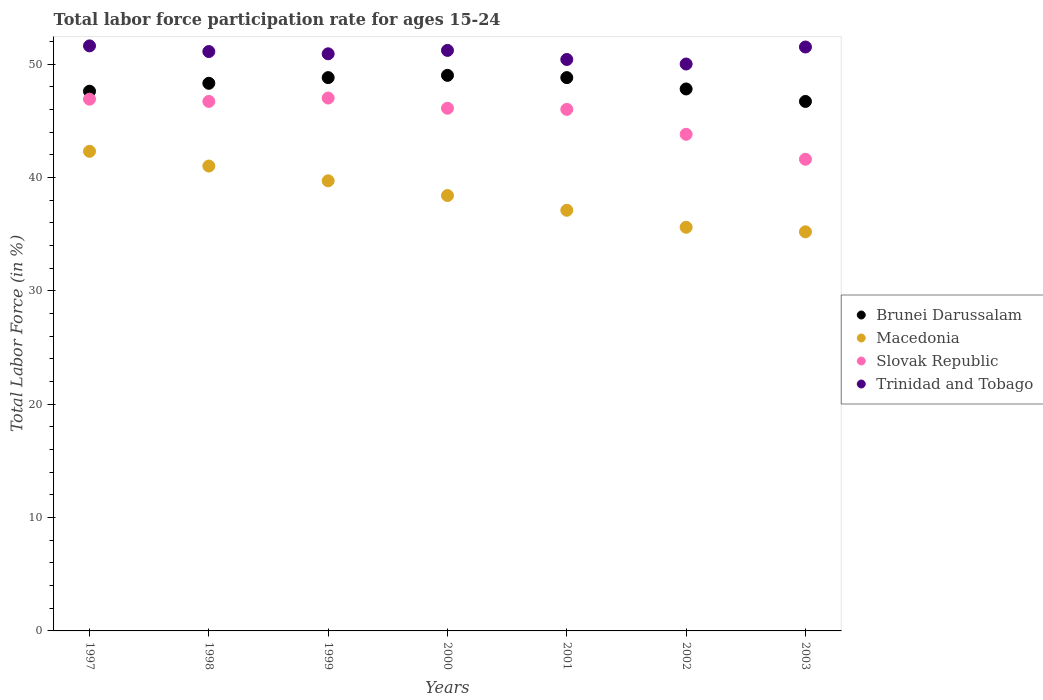How many different coloured dotlines are there?
Provide a succinct answer. 4. What is the labor force participation rate in Brunei Darussalam in 1999?
Offer a very short reply. 48.8. Across all years, what is the maximum labor force participation rate in Trinidad and Tobago?
Provide a succinct answer. 51.6. Across all years, what is the minimum labor force participation rate in Brunei Darussalam?
Provide a short and direct response. 46.7. What is the total labor force participation rate in Trinidad and Tobago in the graph?
Your answer should be very brief. 356.7. What is the difference between the labor force participation rate in Macedonia in 1997 and that in 2002?
Your answer should be very brief. 6.7. What is the difference between the labor force participation rate in Brunei Darussalam in 2003 and the labor force participation rate in Macedonia in 2001?
Provide a short and direct response. 9.6. What is the average labor force participation rate in Trinidad and Tobago per year?
Keep it short and to the point. 50.96. In the year 1999, what is the difference between the labor force participation rate in Slovak Republic and labor force participation rate in Macedonia?
Provide a succinct answer. 7.3. In how many years, is the labor force participation rate in Trinidad and Tobago greater than 50 %?
Give a very brief answer. 6. What is the ratio of the labor force participation rate in Brunei Darussalam in 1997 to that in 1999?
Make the answer very short. 0.98. Is the labor force participation rate in Trinidad and Tobago in 1998 less than that in 2002?
Provide a succinct answer. No. Is the difference between the labor force participation rate in Slovak Republic in 1998 and 2000 greater than the difference between the labor force participation rate in Macedonia in 1998 and 2000?
Your response must be concise. No. What is the difference between the highest and the second highest labor force participation rate in Macedonia?
Provide a short and direct response. 1.3. What is the difference between the highest and the lowest labor force participation rate in Slovak Republic?
Provide a succinct answer. 5.4. In how many years, is the labor force participation rate in Trinidad and Tobago greater than the average labor force participation rate in Trinidad and Tobago taken over all years?
Your answer should be compact. 4. Is the sum of the labor force participation rate in Macedonia in 1997 and 2003 greater than the maximum labor force participation rate in Trinidad and Tobago across all years?
Give a very brief answer. Yes. How many years are there in the graph?
Your response must be concise. 7. Does the graph contain any zero values?
Your answer should be compact. No. Does the graph contain grids?
Make the answer very short. No. What is the title of the graph?
Give a very brief answer. Total labor force participation rate for ages 15-24. Does "Djibouti" appear as one of the legend labels in the graph?
Your answer should be very brief. No. What is the label or title of the X-axis?
Provide a short and direct response. Years. What is the Total Labor Force (in %) of Brunei Darussalam in 1997?
Your response must be concise. 47.6. What is the Total Labor Force (in %) in Macedonia in 1997?
Your answer should be very brief. 42.3. What is the Total Labor Force (in %) in Slovak Republic in 1997?
Make the answer very short. 46.9. What is the Total Labor Force (in %) in Trinidad and Tobago in 1997?
Make the answer very short. 51.6. What is the Total Labor Force (in %) of Brunei Darussalam in 1998?
Make the answer very short. 48.3. What is the Total Labor Force (in %) of Macedonia in 1998?
Give a very brief answer. 41. What is the Total Labor Force (in %) in Slovak Republic in 1998?
Provide a short and direct response. 46.7. What is the Total Labor Force (in %) in Trinidad and Tobago in 1998?
Make the answer very short. 51.1. What is the Total Labor Force (in %) of Brunei Darussalam in 1999?
Provide a short and direct response. 48.8. What is the Total Labor Force (in %) in Macedonia in 1999?
Your answer should be very brief. 39.7. What is the Total Labor Force (in %) in Trinidad and Tobago in 1999?
Offer a terse response. 50.9. What is the Total Labor Force (in %) in Brunei Darussalam in 2000?
Provide a short and direct response. 49. What is the Total Labor Force (in %) of Macedonia in 2000?
Offer a very short reply. 38.4. What is the Total Labor Force (in %) of Slovak Republic in 2000?
Provide a short and direct response. 46.1. What is the Total Labor Force (in %) of Trinidad and Tobago in 2000?
Give a very brief answer. 51.2. What is the Total Labor Force (in %) in Brunei Darussalam in 2001?
Give a very brief answer. 48.8. What is the Total Labor Force (in %) in Macedonia in 2001?
Your answer should be compact. 37.1. What is the Total Labor Force (in %) in Slovak Republic in 2001?
Make the answer very short. 46. What is the Total Labor Force (in %) in Trinidad and Tobago in 2001?
Provide a succinct answer. 50.4. What is the Total Labor Force (in %) in Brunei Darussalam in 2002?
Your answer should be very brief. 47.8. What is the Total Labor Force (in %) in Macedonia in 2002?
Your response must be concise. 35.6. What is the Total Labor Force (in %) in Slovak Republic in 2002?
Your answer should be very brief. 43.8. What is the Total Labor Force (in %) in Trinidad and Tobago in 2002?
Keep it short and to the point. 50. What is the Total Labor Force (in %) of Brunei Darussalam in 2003?
Make the answer very short. 46.7. What is the Total Labor Force (in %) in Macedonia in 2003?
Make the answer very short. 35.2. What is the Total Labor Force (in %) in Slovak Republic in 2003?
Your answer should be very brief. 41.6. What is the Total Labor Force (in %) in Trinidad and Tobago in 2003?
Provide a succinct answer. 51.5. Across all years, what is the maximum Total Labor Force (in %) in Macedonia?
Keep it short and to the point. 42.3. Across all years, what is the maximum Total Labor Force (in %) of Trinidad and Tobago?
Give a very brief answer. 51.6. Across all years, what is the minimum Total Labor Force (in %) of Brunei Darussalam?
Give a very brief answer. 46.7. Across all years, what is the minimum Total Labor Force (in %) of Macedonia?
Give a very brief answer. 35.2. Across all years, what is the minimum Total Labor Force (in %) in Slovak Republic?
Offer a terse response. 41.6. What is the total Total Labor Force (in %) of Brunei Darussalam in the graph?
Offer a terse response. 337. What is the total Total Labor Force (in %) of Macedonia in the graph?
Provide a short and direct response. 269.3. What is the total Total Labor Force (in %) in Slovak Republic in the graph?
Your answer should be compact. 318.1. What is the total Total Labor Force (in %) in Trinidad and Tobago in the graph?
Ensure brevity in your answer.  356.7. What is the difference between the Total Labor Force (in %) of Slovak Republic in 1997 and that in 1998?
Ensure brevity in your answer.  0.2. What is the difference between the Total Labor Force (in %) of Trinidad and Tobago in 1997 and that in 1998?
Your response must be concise. 0.5. What is the difference between the Total Labor Force (in %) of Macedonia in 1997 and that in 1999?
Make the answer very short. 2.6. What is the difference between the Total Labor Force (in %) in Slovak Republic in 1997 and that in 1999?
Give a very brief answer. -0.1. What is the difference between the Total Labor Force (in %) of Brunei Darussalam in 1997 and that in 2000?
Your response must be concise. -1.4. What is the difference between the Total Labor Force (in %) in Macedonia in 1997 and that in 2000?
Provide a short and direct response. 3.9. What is the difference between the Total Labor Force (in %) in Slovak Republic in 1997 and that in 2000?
Provide a short and direct response. 0.8. What is the difference between the Total Labor Force (in %) of Brunei Darussalam in 1997 and that in 2001?
Keep it short and to the point. -1.2. What is the difference between the Total Labor Force (in %) in Macedonia in 1997 and that in 2001?
Your response must be concise. 5.2. What is the difference between the Total Labor Force (in %) of Slovak Republic in 1997 and that in 2001?
Offer a terse response. 0.9. What is the difference between the Total Labor Force (in %) of Trinidad and Tobago in 1997 and that in 2001?
Give a very brief answer. 1.2. What is the difference between the Total Labor Force (in %) in Brunei Darussalam in 1997 and that in 2002?
Offer a terse response. -0.2. What is the difference between the Total Labor Force (in %) of Slovak Republic in 1997 and that in 2002?
Provide a succinct answer. 3.1. What is the difference between the Total Labor Force (in %) in Trinidad and Tobago in 1997 and that in 2002?
Give a very brief answer. 1.6. What is the difference between the Total Labor Force (in %) in Slovak Republic in 1997 and that in 2003?
Offer a terse response. 5.3. What is the difference between the Total Labor Force (in %) of Slovak Republic in 1998 and that in 2000?
Provide a succinct answer. 0.6. What is the difference between the Total Labor Force (in %) of Trinidad and Tobago in 1998 and that in 2000?
Offer a terse response. -0.1. What is the difference between the Total Labor Force (in %) of Brunei Darussalam in 1998 and that in 2001?
Provide a short and direct response. -0.5. What is the difference between the Total Labor Force (in %) of Brunei Darussalam in 1998 and that in 2002?
Offer a terse response. 0.5. What is the difference between the Total Labor Force (in %) of Macedonia in 1998 and that in 2002?
Keep it short and to the point. 5.4. What is the difference between the Total Labor Force (in %) in Slovak Republic in 1998 and that in 2002?
Keep it short and to the point. 2.9. What is the difference between the Total Labor Force (in %) in Slovak Republic in 1998 and that in 2003?
Your response must be concise. 5.1. What is the difference between the Total Labor Force (in %) of Trinidad and Tobago in 1998 and that in 2003?
Give a very brief answer. -0.4. What is the difference between the Total Labor Force (in %) of Brunei Darussalam in 1999 and that in 2000?
Offer a very short reply. -0.2. What is the difference between the Total Labor Force (in %) in Slovak Republic in 1999 and that in 2000?
Keep it short and to the point. 0.9. What is the difference between the Total Labor Force (in %) of Trinidad and Tobago in 1999 and that in 2000?
Your answer should be compact. -0.3. What is the difference between the Total Labor Force (in %) of Brunei Darussalam in 1999 and that in 2001?
Keep it short and to the point. 0. What is the difference between the Total Labor Force (in %) in Macedonia in 1999 and that in 2001?
Keep it short and to the point. 2.6. What is the difference between the Total Labor Force (in %) of Trinidad and Tobago in 1999 and that in 2001?
Give a very brief answer. 0.5. What is the difference between the Total Labor Force (in %) of Macedonia in 1999 and that in 2002?
Ensure brevity in your answer.  4.1. What is the difference between the Total Labor Force (in %) in Trinidad and Tobago in 1999 and that in 2002?
Make the answer very short. 0.9. What is the difference between the Total Labor Force (in %) of Macedonia in 1999 and that in 2003?
Offer a very short reply. 4.5. What is the difference between the Total Labor Force (in %) of Slovak Republic in 2000 and that in 2001?
Provide a succinct answer. 0.1. What is the difference between the Total Labor Force (in %) of Brunei Darussalam in 2000 and that in 2002?
Give a very brief answer. 1.2. What is the difference between the Total Labor Force (in %) of Slovak Republic in 2000 and that in 2003?
Ensure brevity in your answer.  4.5. What is the difference between the Total Labor Force (in %) in Brunei Darussalam in 2001 and that in 2002?
Your answer should be very brief. 1. What is the difference between the Total Labor Force (in %) in Macedonia in 2001 and that in 2002?
Offer a very short reply. 1.5. What is the difference between the Total Labor Force (in %) of Slovak Republic in 2001 and that in 2002?
Make the answer very short. 2.2. What is the difference between the Total Labor Force (in %) of Slovak Republic in 2001 and that in 2003?
Give a very brief answer. 4.4. What is the difference between the Total Labor Force (in %) in Trinidad and Tobago in 2001 and that in 2003?
Your answer should be compact. -1.1. What is the difference between the Total Labor Force (in %) of Brunei Darussalam in 2002 and that in 2003?
Offer a very short reply. 1.1. What is the difference between the Total Labor Force (in %) in Trinidad and Tobago in 2002 and that in 2003?
Your answer should be very brief. -1.5. What is the difference between the Total Labor Force (in %) of Brunei Darussalam in 1997 and the Total Labor Force (in %) of Macedonia in 1998?
Ensure brevity in your answer.  6.6. What is the difference between the Total Labor Force (in %) in Brunei Darussalam in 1997 and the Total Labor Force (in %) in Trinidad and Tobago in 1998?
Offer a very short reply. -3.5. What is the difference between the Total Labor Force (in %) in Macedonia in 1997 and the Total Labor Force (in %) in Trinidad and Tobago in 1998?
Offer a terse response. -8.8. What is the difference between the Total Labor Force (in %) in Brunei Darussalam in 1997 and the Total Labor Force (in %) in Macedonia in 1999?
Give a very brief answer. 7.9. What is the difference between the Total Labor Force (in %) in Brunei Darussalam in 1997 and the Total Labor Force (in %) in Slovak Republic in 1999?
Provide a short and direct response. 0.6. What is the difference between the Total Labor Force (in %) in Macedonia in 1997 and the Total Labor Force (in %) in Slovak Republic in 1999?
Keep it short and to the point. -4.7. What is the difference between the Total Labor Force (in %) of Macedonia in 1997 and the Total Labor Force (in %) of Trinidad and Tobago in 1999?
Provide a succinct answer. -8.6. What is the difference between the Total Labor Force (in %) in Slovak Republic in 1997 and the Total Labor Force (in %) in Trinidad and Tobago in 1999?
Your answer should be compact. -4. What is the difference between the Total Labor Force (in %) of Brunei Darussalam in 1997 and the Total Labor Force (in %) of Slovak Republic in 2000?
Your response must be concise. 1.5. What is the difference between the Total Labor Force (in %) in Macedonia in 1997 and the Total Labor Force (in %) in Trinidad and Tobago in 2000?
Offer a very short reply. -8.9. What is the difference between the Total Labor Force (in %) of Brunei Darussalam in 1997 and the Total Labor Force (in %) of Slovak Republic in 2001?
Ensure brevity in your answer.  1.6. What is the difference between the Total Labor Force (in %) of Brunei Darussalam in 1997 and the Total Labor Force (in %) of Trinidad and Tobago in 2001?
Make the answer very short. -2.8. What is the difference between the Total Labor Force (in %) in Macedonia in 1997 and the Total Labor Force (in %) in Trinidad and Tobago in 2001?
Offer a very short reply. -8.1. What is the difference between the Total Labor Force (in %) in Slovak Republic in 1997 and the Total Labor Force (in %) in Trinidad and Tobago in 2001?
Your answer should be very brief. -3.5. What is the difference between the Total Labor Force (in %) of Brunei Darussalam in 1997 and the Total Labor Force (in %) of Slovak Republic in 2002?
Provide a short and direct response. 3.8. What is the difference between the Total Labor Force (in %) in Brunei Darussalam in 1997 and the Total Labor Force (in %) in Trinidad and Tobago in 2002?
Keep it short and to the point. -2.4. What is the difference between the Total Labor Force (in %) of Macedonia in 1997 and the Total Labor Force (in %) of Slovak Republic in 2002?
Ensure brevity in your answer.  -1.5. What is the difference between the Total Labor Force (in %) of Slovak Republic in 1997 and the Total Labor Force (in %) of Trinidad and Tobago in 2002?
Give a very brief answer. -3.1. What is the difference between the Total Labor Force (in %) in Brunei Darussalam in 1997 and the Total Labor Force (in %) in Macedonia in 2003?
Provide a short and direct response. 12.4. What is the difference between the Total Labor Force (in %) of Brunei Darussalam in 1997 and the Total Labor Force (in %) of Slovak Republic in 2003?
Provide a short and direct response. 6. What is the difference between the Total Labor Force (in %) of Brunei Darussalam in 1997 and the Total Labor Force (in %) of Trinidad and Tobago in 2003?
Your response must be concise. -3.9. What is the difference between the Total Labor Force (in %) in Macedonia in 1997 and the Total Labor Force (in %) in Slovak Republic in 2003?
Your answer should be very brief. 0.7. What is the difference between the Total Labor Force (in %) in Macedonia in 1997 and the Total Labor Force (in %) in Trinidad and Tobago in 2003?
Give a very brief answer. -9.2. What is the difference between the Total Labor Force (in %) of Brunei Darussalam in 1998 and the Total Labor Force (in %) of Macedonia in 1999?
Keep it short and to the point. 8.6. What is the difference between the Total Labor Force (in %) of Brunei Darussalam in 1998 and the Total Labor Force (in %) of Trinidad and Tobago in 1999?
Make the answer very short. -2.6. What is the difference between the Total Labor Force (in %) of Macedonia in 1998 and the Total Labor Force (in %) of Slovak Republic in 1999?
Your response must be concise. -6. What is the difference between the Total Labor Force (in %) in Brunei Darussalam in 1998 and the Total Labor Force (in %) in Macedonia in 2000?
Provide a succinct answer. 9.9. What is the difference between the Total Labor Force (in %) in Brunei Darussalam in 1998 and the Total Labor Force (in %) in Macedonia in 2001?
Give a very brief answer. 11.2. What is the difference between the Total Labor Force (in %) of Macedonia in 1998 and the Total Labor Force (in %) of Slovak Republic in 2001?
Make the answer very short. -5. What is the difference between the Total Labor Force (in %) of Slovak Republic in 1998 and the Total Labor Force (in %) of Trinidad and Tobago in 2001?
Give a very brief answer. -3.7. What is the difference between the Total Labor Force (in %) in Brunei Darussalam in 1998 and the Total Labor Force (in %) in Macedonia in 2002?
Ensure brevity in your answer.  12.7. What is the difference between the Total Labor Force (in %) in Brunei Darussalam in 1998 and the Total Labor Force (in %) in Slovak Republic in 2002?
Ensure brevity in your answer.  4.5. What is the difference between the Total Labor Force (in %) of Brunei Darussalam in 1998 and the Total Labor Force (in %) of Trinidad and Tobago in 2002?
Your response must be concise. -1.7. What is the difference between the Total Labor Force (in %) of Macedonia in 1998 and the Total Labor Force (in %) of Slovak Republic in 2002?
Your response must be concise. -2.8. What is the difference between the Total Labor Force (in %) of Macedonia in 1998 and the Total Labor Force (in %) of Trinidad and Tobago in 2002?
Your response must be concise. -9. What is the difference between the Total Labor Force (in %) of Slovak Republic in 1998 and the Total Labor Force (in %) of Trinidad and Tobago in 2002?
Provide a succinct answer. -3.3. What is the difference between the Total Labor Force (in %) in Brunei Darussalam in 1998 and the Total Labor Force (in %) in Slovak Republic in 2003?
Your answer should be compact. 6.7. What is the difference between the Total Labor Force (in %) in Macedonia in 1999 and the Total Labor Force (in %) in Slovak Republic in 2000?
Your answer should be very brief. -6.4. What is the difference between the Total Labor Force (in %) of Slovak Republic in 1999 and the Total Labor Force (in %) of Trinidad and Tobago in 2001?
Provide a short and direct response. -3.4. What is the difference between the Total Labor Force (in %) in Brunei Darussalam in 1999 and the Total Labor Force (in %) in Slovak Republic in 2002?
Your response must be concise. 5. What is the difference between the Total Labor Force (in %) of Brunei Darussalam in 1999 and the Total Labor Force (in %) of Trinidad and Tobago in 2002?
Provide a short and direct response. -1.2. What is the difference between the Total Labor Force (in %) in Macedonia in 1999 and the Total Labor Force (in %) in Trinidad and Tobago in 2002?
Make the answer very short. -10.3. What is the difference between the Total Labor Force (in %) of Slovak Republic in 1999 and the Total Labor Force (in %) of Trinidad and Tobago in 2002?
Offer a terse response. -3. What is the difference between the Total Labor Force (in %) in Brunei Darussalam in 1999 and the Total Labor Force (in %) in Macedonia in 2003?
Your response must be concise. 13.6. What is the difference between the Total Labor Force (in %) of Brunei Darussalam in 1999 and the Total Labor Force (in %) of Slovak Republic in 2003?
Ensure brevity in your answer.  7.2. What is the difference between the Total Labor Force (in %) of Brunei Darussalam in 1999 and the Total Labor Force (in %) of Trinidad and Tobago in 2003?
Your answer should be compact. -2.7. What is the difference between the Total Labor Force (in %) in Macedonia in 1999 and the Total Labor Force (in %) in Trinidad and Tobago in 2003?
Ensure brevity in your answer.  -11.8. What is the difference between the Total Labor Force (in %) of Brunei Darussalam in 2000 and the Total Labor Force (in %) of Slovak Republic in 2001?
Ensure brevity in your answer.  3. What is the difference between the Total Labor Force (in %) of Brunei Darussalam in 2000 and the Total Labor Force (in %) of Trinidad and Tobago in 2001?
Offer a terse response. -1.4. What is the difference between the Total Labor Force (in %) of Macedonia in 2000 and the Total Labor Force (in %) of Trinidad and Tobago in 2001?
Give a very brief answer. -12. What is the difference between the Total Labor Force (in %) of Brunei Darussalam in 2000 and the Total Labor Force (in %) of Slovak Republic in 2002?
Offer a terse response. 5.2. What is the difference between the Total Labor Force (in %) in Brunei Darussalam in 2000 and the Total Labor Force (in %) in Trinidad and Tobago in 2002?
Your answer should be compact. -1. What is the difference between the Total Labor Force (in %) of Macedonia in 2000 and the Total Labor Force (in %) of Slovak Republic in 2002?
Offer a terse response. -5.4. What is the difference between the Total Labor Force (in %) in Brunei Darussalam in 2000 and the Total Labor Force (in %) in Slovak Republic in 2003?
Provide a short and direct response. 7.4. What is the difference between the Total Labor Force (in %) in Brunei Darussalam in 2000 and the Total Labor Force (in %) in Trinidad and Tobago in 2003?
Your answer should be very brief. -2.5. What is the difference between the Total Labor Force (in %) of Slovak Republic in 2000 and the Total Labor Force (in %) of Trinidad and Tobago in 2003?
Offer a very short reply. -5.4. What is the difference between the Total Labor Force (in %) in Brunei Darussalam in 2001 and the Total Labor Force (in %) in Macedonia in 2002?
Offer a terse response. 13.2. What is the difference between the Total Labor Force (in %) in Brunei Darussalam in 2001 and the Total Labor Force (in %) in Trinidad and Tobago in 2002?
Ensure brevity in your answer.  -1.2. What is the difference between the Total Labor Force (in %) of Macedonia in 2001 and the Total Labor Force (in %) of Trinidad and Tobago in 2002?
Keep it short and to the point. -12.9. What is the difference between the Total Labor Force (in %) of Slovak Republic in 2001 and the Total Labor Force (in %) of Trinidad and Tobago in 2002?
Keep it short and to the point. -4. What is the difference between the Total Labor Force (in %) of Brunei Darussalam in 2001 and the Total Labor Force (in %) of Macedonia in 2003?
Your answer should be compact. 13.6. What is the difference between the Total Labor Force (in %) of Macedonia in 2001 and the Total Labor Force (in %) of Trinidad and Tobago in 2003?
Make the answer very short. -14.4. What is the difference between the Total Labor Force (in %) in Slovak Republic in 2001 and the Total Labor Force (in %) in Trinidad and Tobago in 2003?
Provide a short and direct response. -5.5. What is the difference between the Total Labor Force (in %) in Brunei Darussalam in 2002 and the Total Labor Force (in %) in Slovak Republic in 2003?
Give a very brief answer. 6.2. What is the difference between the Total Labor Force (in %) in Macedonia in 2002 and the Total Labor Force (in %) in Trinidad and Tobago in 2003?
Your answer should be very brief. -15.9. What is the difference between the Total Labor Force (in %) of Slovak Republic in 2002 and the Total Labor Force (in %) of Trinidad and Tobago in 2003?
Provide a succinct answer. -7.7. What is the average Total Labor Force (in %) in Brunei Darussalam per year?
Your response must be concise. 48.14. What is the average Total Labor Force (in %) of Macedonia per year?
Keep it short and to the point. 38.47. What is the average Total Labor Force (in %) of Slovak Republic per year?
Provide a short and direct response. 45.44. What is the average Total Labor Force (in %) in Trinidad and Tobago per year?
Offer a terse response. 50.96. In the year 1997, what is the difference between the Total Labor Force (in %) of Brunei Darussalam and Total Labor Force (in %) of Slovak Republic?
Make the answer very short. 0.7. In the year 1997, what is the difference between the Total Labor Force (in %) in Brunei Darussalam and Total Labor Force (in %) in Trinidad and Tobago?
Give a very brief answer. -4. In the year 1998, what is the difference between the Total Labor Force (in %) in Brunei Darussalam and Total Labor Force (in %) in Macedonia?
Keep it short and to the point. 7.3. In the year 1998, what is the difference between the Total Labor Force (in %) of Brunei Darussalam and Total Labor Force (in %) of Slovak Republic?
Ensure brevity in your answer.  1.6. In the year 1998, what is the difference between the Total Labor Force (in %) of Brunei Darussalam and Total Labor Force (in %) of Trinidad and Tobago?
Give a very brief answer. -2.8. In the year 1998, what is the difference between the Total Labor Force (in %) of Macedonia and Total Labor Force (in %) of Slovak Republic?
Your answer should be very brief. -5.7. In the year 1998, what is the difference between the Total Labor Force (in %) in Macedonia and Total Labor Force (in %) in Trinidad and Tobago?
Your answer should be compact. -10.1. In the year 1999, what is the difference between the Total Labor Force (in %) of Brunei Darussalam and Total Labor Force (in %) of Macedonia?
Your answer should be very brief. 9.1. In the year 1999, what is the difference between the Total Labor Force (in %) of Brunei Darussalam and Total Labor Force (in %) of Slovak Republic?
Your response must be concise. 1.8. In the year 1999, what is the difference between the Total Labor Force (in %) in Brunei Darussalam and Total Labor Force (in %) in Trinidad and Tobago?
Keep it short and to the point. -2.1. In the year 1999, what is the difference between the Total Labor Force (in %) in Macedonia and Total Labor Force (in %) in Trinidad and Tobago?
Provide a short and direct response. -11.2. In the year 1999, what is the difference between the Total Labor Force (in %) in Slovak Republic and Total Labor Force (in %) in Trinidad and Tobago?
Ensure brevity in your answer.  -3.9. In the year 2000, what is the difference between the Total Labor Force (in %) of Brunei Darussalam and Total Labor Force (in %) of Macedonia?
Keep it short and to the point. 10.6. In the year 2000, what is the difference between the Total Labor Force (in %) in Brunei Darussalam and Total Labor Force (in %) in Trinidad and Tobago?
Offer a terse response. -2.2. In the year 2001, what is the difference between the Total Labor Force (in %) of Brunei Darussalam and Total Labor Force (in %) of Slovak Republic?
Ensure brevity in your answer.  2.8. In the year 2001, what is the difference between the Total Labor Force (in %) in Brunei Darussalam and Total Labor Force (in %) in Trinidad and Tobago?
Give a very brief answer. -1.6. In the year 2001, what is the difference between the Total Labor Force (in %) of Macedonia and Total Labor Force (in %) of Trinidad and Tobago?
Provide a short and direct response. -13.3. In the year 2001, what is the difference between the Total Labor Force (in %) of Slovak Republic and Total Labor Force (in %) of Trinidad and Tobago?
Your response must be concise. -4.4. In the year 2002, what is the difference between the Total Labor Force (in %) in Brunei Darussalam and Total Labor Force (in %) in Macedonia?
Your response must be concise. 12.2. In the year 2002, what is the difference between the Total Labor Force (in %) in Brunei Darussalam and Total Labor Force (in %) in Slovak Republic?
Offer a very short reply. 4. In the year 2002, what is the difference between the Total Labor Force (in %) of Brunei Darussalam and Total Labor Force (in %) of Trinidad and Tobago?
Ensure brevity in your answer.  -2.2. In the year 2002, what is the difference between the Total Labor Force (in %) of Macedonia and Total Labor Force (in %) of Slovak Republic?
Make the answer very short. -8.2. In the year 2002, what is the difference between the Total Labor Force (in %) of Macedonia and Total Labor Force (in %) of Trinidad and Tobago?
Offer a terse response. -14.4. In the year 2002, what is the difference between the Total Labor Force (in %) of Slovak Republic and Total Labor Force (in %) of Trinidad and Tobago?
Provide a short and direct response. -6.2. In the year 2003, what is the difference between the Total Labor Force (in %) in Brunei Darussalam and Total Labor Force (in %) in Slovak Republic?
Keep it short and to the point. 5.1. In the year 2003, what is the difference between the Total Labor Force (in %) in Macedonia and Total Labor Force (in %) in Trinidad and Tobago?
Offer a very short reply. -16.3. In the year 2003, what is the difference between the Total Labor Force (in %) of Slovak Republic and Total Labor Force (in %) of Trinidad and Tobago?
Keep it short and to the point. -9.9. What is the ratio of the Total Labor Force (in %) of Brunei Darussalam in 1997 to that in 1998?
Keep it short and to the point. 0.99. What is the ratio of the Total Labor Force (in %) in Macedonia in 1997 to that in 1998?
Ensure brevity in your answer.  1.03. What is the ratio of the Total Labor Force (in %) of Trinidad and Tobago in 1997 to that in 1998?
Keep it short and to the point. 1.01. What is the ratio of the Total Labor Force (in %) in Brunei Darussalam in 1997 to that in 1999?
Provide a short and direct response. 0.98. What is the ratio of the Total Labor Force (in %) in Macedonia in 1997 to that in 1999?
Your answer should be very brief. 1.07. What is the ratio of the Total Labor Force (in %) in Slovak Republic in 1997 to that in 1999?
Make the answer very short. 1. What is the ratio of the Total Labor Force (in %) in Trinidad and Tobago in 1997 to that in 1999?
Provide a succinct answer. 1.01. What is the ratio of the Total Labor Force (in %) of Brunei Darussalam in 1997 to that in 2000?
Offer a very short reply. 0.97. What is the ratio of the Total Labor Force (in %) of Macedonia in 1997 to that in 2000?
Your answer should be very brief. 1.1. What is the ratio of the Total Labor Force (in %) in Slovak Republic in 1997 to that in 2000?
Your answer should be compact. 1.02. What is the ratio of the Total Labor Force (in %) of Brunei Darussalam in 1997 to that in 2001?
Make the answer very short. 0.98. What is the ratio of the Total Labor Force (in %) of Macedonia in 1997 to that in 2001?
Ensure brevity in your answer.  1.14. What is the ratio of the Total Labor Force (in %) of Slovak Republic in 1997 to that in 2001?
Offer a very short reply. 1.02. What is the ratio of the Total Labor Force (in %) in Trinidad and Tobago in 1997 to that in 2001?
Your answer should be very brief. 1.02. What is the ratio of the Total Labor Force (in %) in Macedonia in 1997 to that in 2002?
Make the answer very short. 1.19. What is the ratio of the Total Labor Force (in %) in Slovak Republic in 1997 to that in 2002?
Offer a very short reply. 1.07. What is the ratio of the Total Labor Force (in %) in Trinidad and Tobago in 1997 to that in 2002?
Provide a short and direct response. 1.03. What is the ratio of the Total Labor Force (in %) of Brunei Darussalam in 1997 to that in 2003?
Provide a short and direct response. 1.02. What is the ratio of the Total Labor Force (in %) of Macedonia in 1997 to that in 2003?
Offer a terse response. 1.2. What is the ratio of the Total Labor Force (in %) in Slovak Republic in 1997 to that in 2003?
Provide a short and direct response. 1.13. What is the ratio of the Total Labor Force (in %) of Macedonia in 1998 to that in 1999?
Keep it short and to the point. 1.03. What is the ratio of the Total Labor Force (in %) in Trinidad and Tobago in 1998 to that in 1999?
Provide a succinct answer. 1. What is the ratio of the Total Labor Force (in %) in Brunei Darussalam in 1998 to that in 2000?
Provide a succinct answer. 0.99. What is the ratio of the Total Labor Force (in %) of Macedonia in 1998 to that in 2000?
Your response must be concise. 1.07. What is the ratio of the Total Labor Force (in %) of Slovak Republic in 1998 to that in 2000?
Your response must be concise. 1.01. What is the ratio of the Total Labor Force (in %) in Brunei Darussalam in 1998 to that in 2001?
Provide a succinct answer. 0.99. What is the ratio of the Total Labor Force (in %) in Macedonia in 1998 to that in 2001?
Keep it short and to the point. 1.11. What is the ratio of the Total Labor Force (in %) of Slovak Republic in 1998 to that in 2001?
Your response must be concise. 1.02. What is the ratio of the Total Labor Force (in %) of Trinidad and Tobago in 1998 to that in 2001?
Give a very brief answer. 1.01. What is the ratio of the Total Labor Force (in %) of Brunei Darussalam in 1998 to that in 2002?
Offer a very short reply. 1.01. What is the ratio of the Total Labor Force (in %) in Macedonia in 1998 to that in 2002?
Make the answer very short. 1.15. What is the ratio of the Total Labor Force (in %) in Slovak Republic in 1998 to that in 2002?
Ensure brevity in your answer.  1.07. What is the ratio of the Total Labor Force (in %) in Trinidad and Tobago in 1998 to that in 2002?
Your response must be concise. 1.02. What is the ratio of the Total Labor Force (in %) of Brunei Darussalam in 1998 to that in 2003?
Your answer should be very brief. 1.03. What is the ratio of the Total Labor Force (in %) of Macedonia in 1998 to that in 2003?
Give a very brief answer. 1.16. What is the ratio of the Total Labor Force (in %) of Slovak Republic in 1998 to that in 2003?
Give a very brief answer. 1.12. What is the ratio of the Total Labor Force (in %) of Trinidad and Tobago in 1998 to that in 2003?
Give a very brief answer. 0.99. What is the ratio of the Total Labor Force (in %) in Brunei Darussalam in 1999 to that in 2000?
Give a very brief answer. 1. What is the ratio of the Total Labor Force (in %) in Macedonia in 1999 to that in 2000?
Your answer should be compact. 1.03. What is the ratio of the Total Labor Force (in %) of Slovak Republic in 1999 to that in 2000?
Provide a short and direct response. 1.02. What is the ratio of the Total Labor Force (in %) in Macedonia in 1999 to that in 2001?
Offer a terse response. 1.07. What is the ratio of the Total Labor Force (in %) in Slovak Republic in 1999 to that in 2001?
Provide a short and direct response. 1.02. What is the ratio of the Total Labor Force (in %) of Trinidad and Tobago in 1999 to that in 2001?
Ensure brevity in your answer.  1.01. What is the ratio of the Total Labor Force (in %) of Brunei Darussalam in 1999 to that in 2002?
Offer a very short reply. 1.02. What is the ratio of the Total Labor Force (in %) of Macedonia in 1999 to that in 2002?
Provide a succinct answer. 1.12. What is the ratio of the Total Labor Force (in %) of Slovak Republic in 1999 to that in 2002?
Offer a very short reply. 1.07. What is the ratio of the Total Labor Force (in %) in Brunei Darussalam in 1999 to that in 2003?
Provide a short and direct response. 1.04. What is the ratio of the Total Labor Force (in %) in Macedonia in 1999 to that in 2003?
Offer a terse response. 1.13. What is the ratio of the Total Labor Force (in %) in Slovak Republic in 1999 to that in 2003?
Your answer should be compact. 1.13. What is the ratio of the Total Labor Force (in %) of Trinidad and Tobago in 1999 to that in 2003?
Offer a terse response. 0.99. What is the ratio of the Total Labor Force (in %) of Macedonia in 2000 to that in 2001?
Give a very brief answer. 1.03. What is the ratio of the Total Labor Force (in %) in Slovak Republic in 2000 to that in 2001?
Make the answer very short. 1. What is the ratio of the Total Labor Force (in %) in Trinidad and Tobago in 2000 to that in 2001?
Offer a very short reply. 1.02. What is the ratio of the Total Labor Force (in %) of Brunei Darussalam in 2000 to that in 2002?
Provide a short and direct response. 1.03. What is the ratio of the Total Labor Force (in %) of Macedonia in 2000 to that in 2002?
Keep it short and to the point. 1.08. What is the ratio of the Total Labor Force (in %) in Slovak Republic in 2000 to that in 2002?
Offer a terse response. 1.05. What is the ratio of the Total Labor Force (in %) in Trinidad and Tobago in 2000 to that in 2002?
Ensure brevity in your answer.  1.02. What is the ratio of the Total Labor Force (in %) of Brunei Darussalam in 2000 to that in 2003?
Offer a very short reply. 1.05. What is the ratio of the Total Labor Force (in %) of Macedonia in 2000 to that in 2003?
Make the answer very short. 1.09. What is the ratio of the Total Labor Force (in %) in Slovak Republic in 2000 to that in 2003?
Your response must be concise. 1.11. What is the ratio of the Total Labor Force (in %) of Trinidad and Tobago in 2000 to that in 2003?
Your answer should be very brief. 0.99. What is the ratio of the Total Labor Force (in %) in Brunei Darussalam in 2001 to that in 2002?
Ensure brevity in your answer.  1.02. What is the ratio of the Total Labor Force (in %) of Macedonia in 2001 to that in 2002?
Make the answer very short. 1.04. What is the ratio of the Total Labor Force (in %) in Slovak Republic in 2001 to that in 2002?
Your response must be concise. 1.05. What is the ratio of the Total Labor Force (in %) in Trinidad and Tobago in 2001 to that in 2002?
Your response must be concise. 1.01. What is the ratio of the Total Labor Force (in %) of Brunei Darussalam in 2001 to that in 2003?
Your answer should be compact. 1.04. What is the ratio of the Total Labor Force (in %) of Macedonia in 2001 to that in 2003?
Your answer should be compact. 1.05. What is the ratio of the Total Labor Force (in %) in Slovak Republic in 2001 to that in 2003?
Provide a succinct answer. 1.11. What is the ratio of the Total Labor Force (in %) in Trinidad and Tobago in 2001 to that in 2003?
Provide a succinct answer. 0.98. What is the ratio of the Total Labor Force (in %) in Brunei Darussalam in 2002 to that in 2003?
Offer a terse response. 1.02. What is the ratio of the Total Labor Force (in %) in Macedonia in 2002 to that in 2003?
Give a very brief answer. 1.01. What is the ratio of the Total Labor Force (in %) of Slovak Republic in 2002 to that in 2003?
Offer a terse response. 1.05. What is the ratio of the Total Labor Force (in %) of Trinidad and Tobago in 2002 to that in 2003?
Make the answer very short. 0.97. What is the difference between the highest and the second highest Total Labor Force (in %) in Brunei Darussalam?
Your answer should be very brief. 0.2. What is the difference between the highest and the second highest Total Labor Force (in %) in Trinidad and Tobago?
Provide a short and direct response. 0.1. 